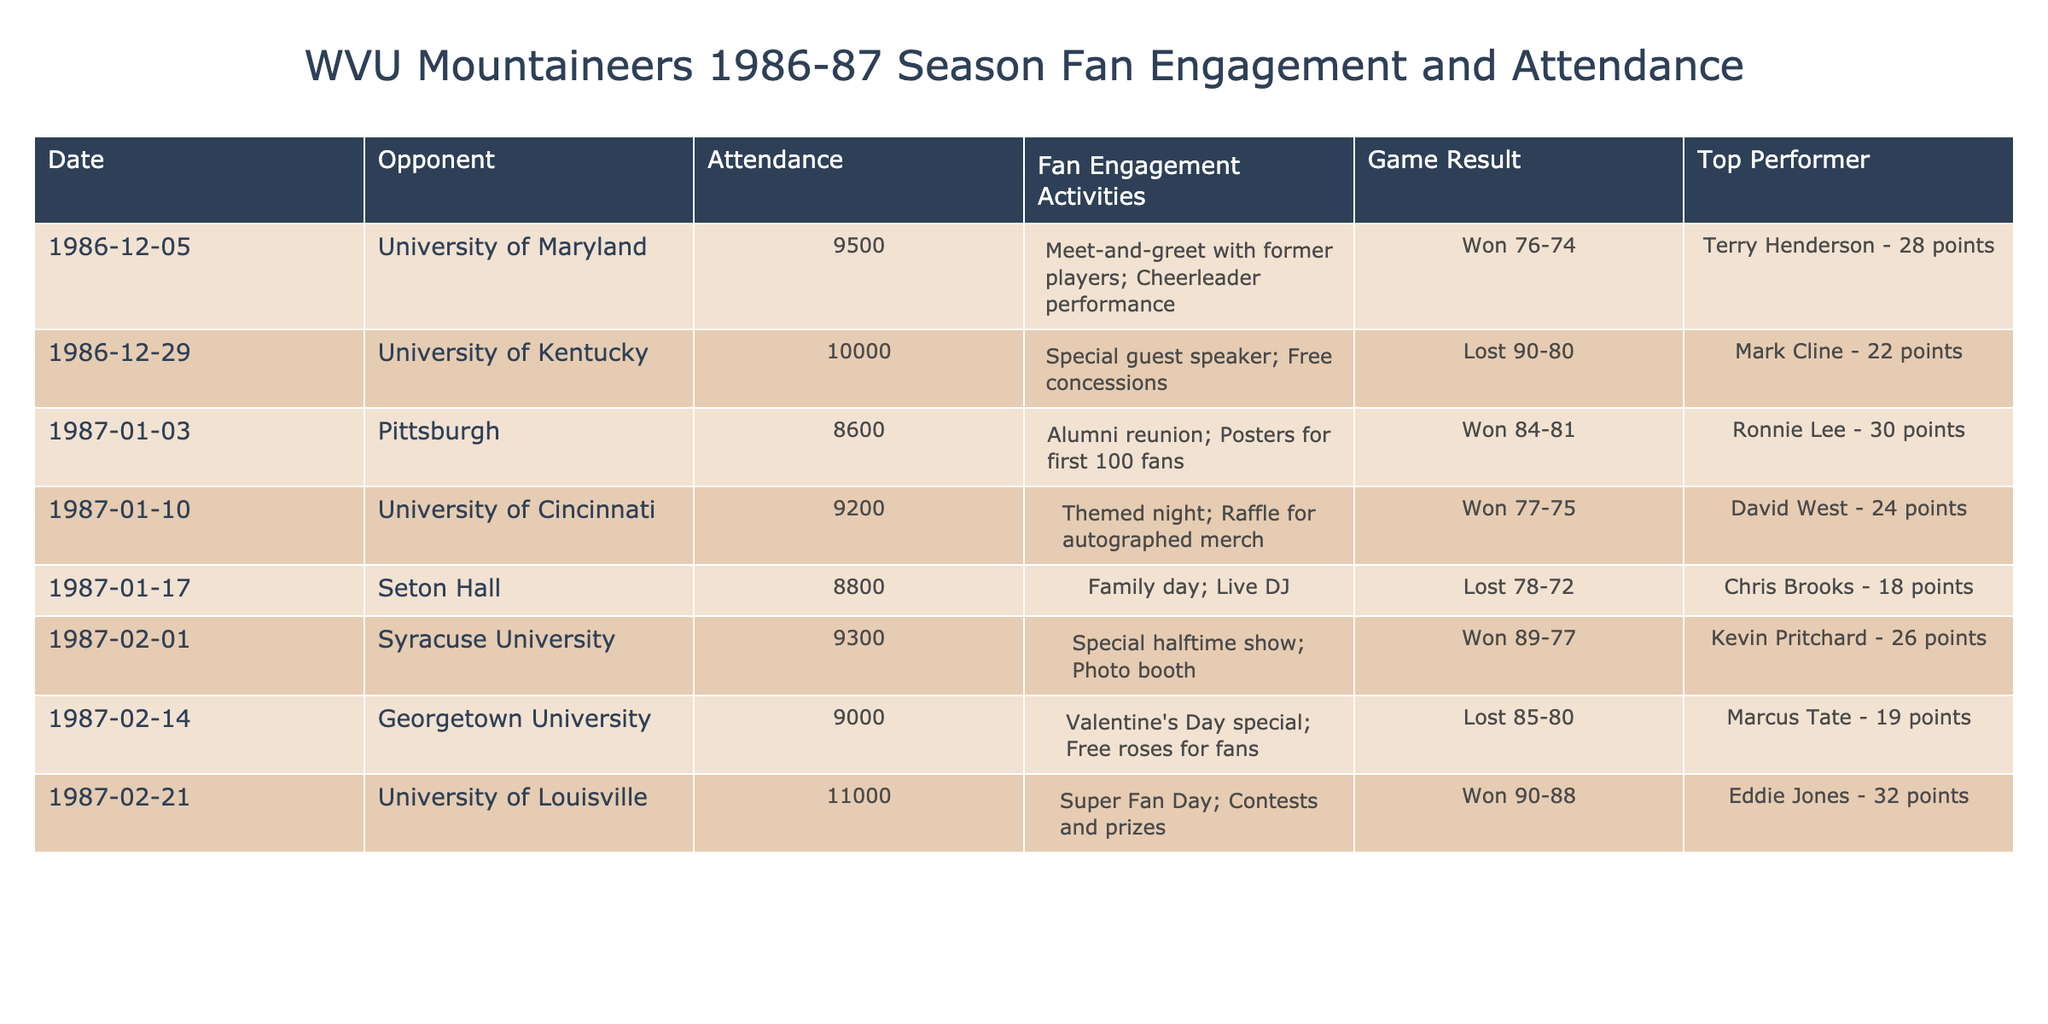What was the highest attendance recorded for a game during the season? The highest attendance listed in the table is 11,000 fans for the game against the University of Louisville on February 21, 1987. I look through the 'Attendance' column and find the maximum number 11,000.
Answer: 11,000 Which opponent did the Mountaineers play on the date of December 29, 1986? The opponent listed for December 29, 1986, is the University of Kentucky as clearly stated in the 'Opponent' column next to the corresponding date.
Answer: University of Kentucky How many games did the Mountaineers win during the season according to the table? To determine the number of wins, I count the rows in the 'Game Result' column that indicate a "Won" outcome. The rows with "Won" are three games: University of Maryland, Pittsburgh, University of Cincinnati, Syracuse University, and University of Louisville, totaling five wins.
Answer: 5 Was there a themed night event during any of the games? Yes, the table shows that there was a "Themed night" event for the game against the University of Cincinnati on January 10, 1987. This is confirmed by checking the 'Fan Engagement Activities' column.
Answer: Yes What was the average attendance for the games that the Mountaineers won? I first identify the attendance numbers for the won games: 9500 (University of Maryland), 8600 (Pittsburgh), 9200 (University of Cincinnati), 9300 (Syracuse), and 11000 (University of Louisville). This gives a total attendance of 9500 + 8600 + 9200 + 9300 + 11000 = 58,600 for five games. I then divide this total by five to find the average: 58600 / 5 = 11,720.
Answer: 11,720 How many fan engagement activities were noted for the games where the Mountaineers lost? The Mountaineers lost three games during the season: to Seton Hall, Georgetown University, and the University of Kentucky. The fan engagement activities noted for these games were as follows: Family day; Live DJ, Valentine's Day special; Free roses for fans, and Special guest speaker; Free concessions. Therefore, there were three distinct engagement activities during the losses.
Answer: 3 